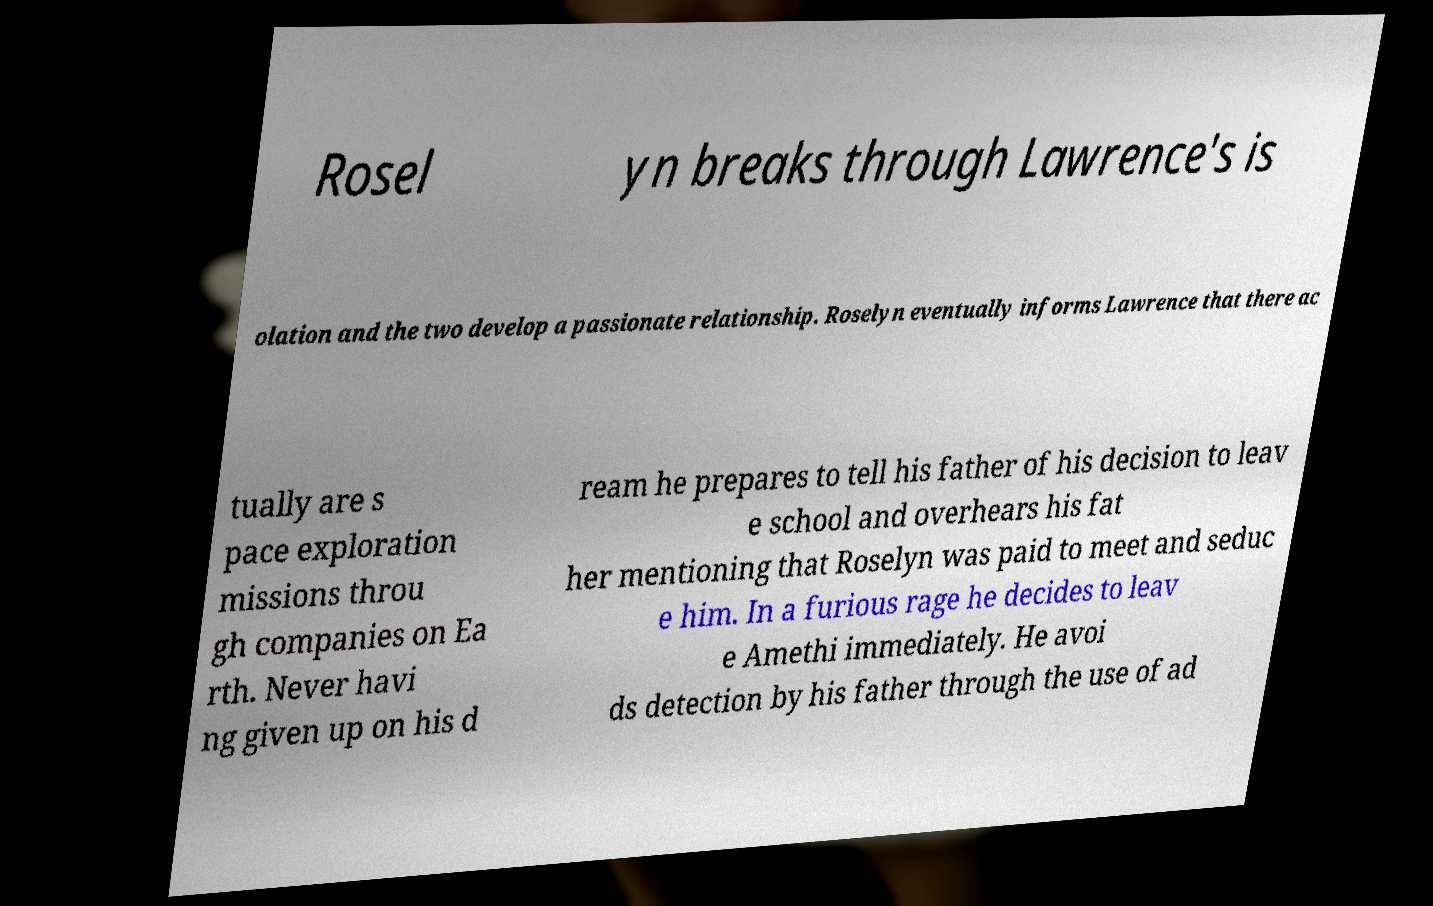Please read and relay the text visible in this image. What does it say? Rosel yn breaks through Lawrence's is olation and the two develop a passionate relationship. Roselyn eventually informs Lawrence that there ac tually are s pace exploration missions throu gh companies on Ea rth. Never havi ng given up on his d ream he prepares to tell his father of his decision to leav e school and overhears his fat her mentioning that Roselyn was paid to meet and seduc e him. In a furious rage he decides to leav e Amethi immediately. He avoi ds detection by his father through the use of ad 